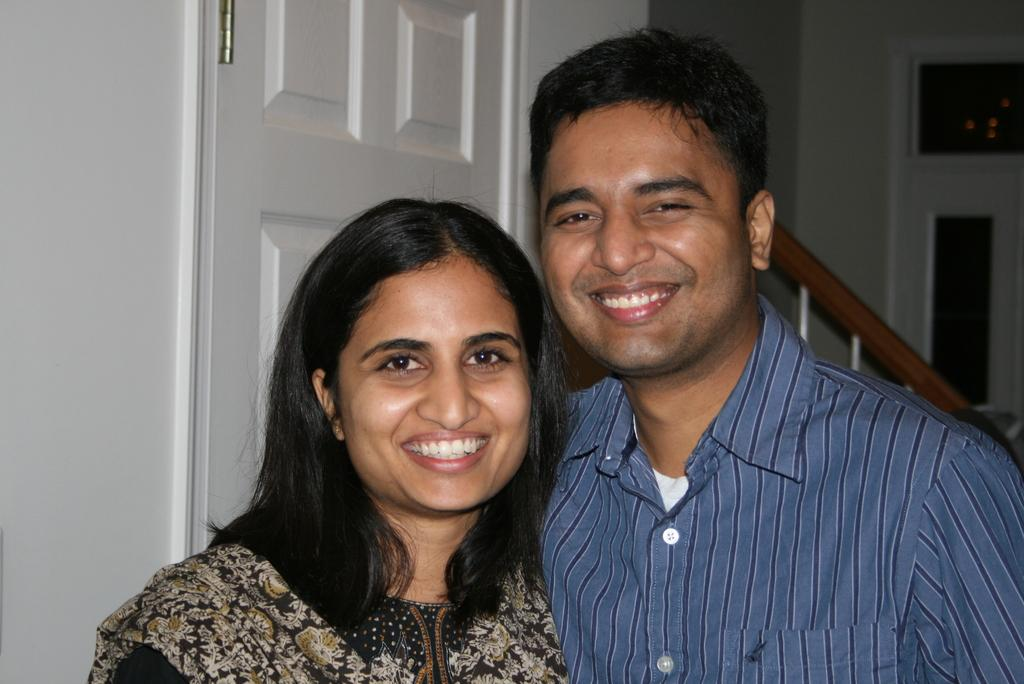How many people are in the image? There are two people in the image. What are the people doing in the image? The people are smiling and posing for a photo. What can be seen behind the people in the image? There is a white color door in the image, and behind the door, there are stairs. How many minutes does it take for the knee to reach the swing in the image? There is no knee or swing present in the image. 